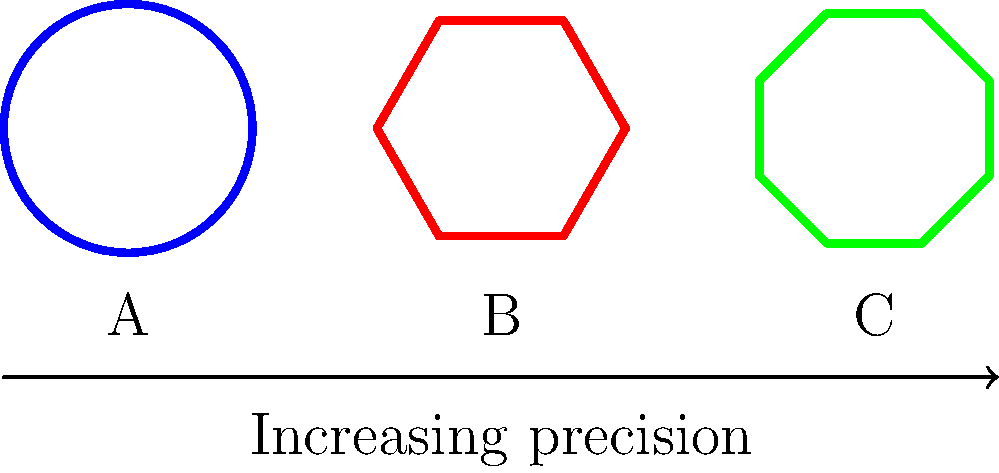As a firearms enthusiast, you're analyzing the rotational symmetry of different rifle barrel designs. The image shows cross-sections of three barrel designs: A (circular), B (hexagonal), and C (octagonal). If we consider the order of rotational symmetry for each design, which of the following statements is true?

a) The sum of the orders of rotational symmetry for all three designs is 14.
b) Design B has twice the order of rotational symmetry as Design A.
c) The product of the orders of rotational symmetry for Designs A and C is 16.
d) The difference between the orders of rotational symmetry of Designs C and B is 2. Let's analyze the rotational symmetry of each design step-by-step:

1. Design A (circular):
   - A circle has infinite rotational symmetry, but in group theory, we consider this as order $\infty$.

2. Design B (hexagonal):
   - A hexagon has 6-fold rotational symmetry, so its order is 6.

3. Design C (octagonal):
   - An octagon has 8-fold rotational symmetry, so its order is 8.

Now, let's evaluate each statement:

a) Sum of orders: $\infty + 6 + 8 = \infty$ (not 14)
b) Design B (6) does not have twice the order of Design A ($\infty$)
c) Product of orders A and C: $\infty \times 8 = \infty$ (not 16)
d) Difference between orders of C and B: $8 - 6 = 2$

Therefore, the only true statement is option d.
Answer: d 